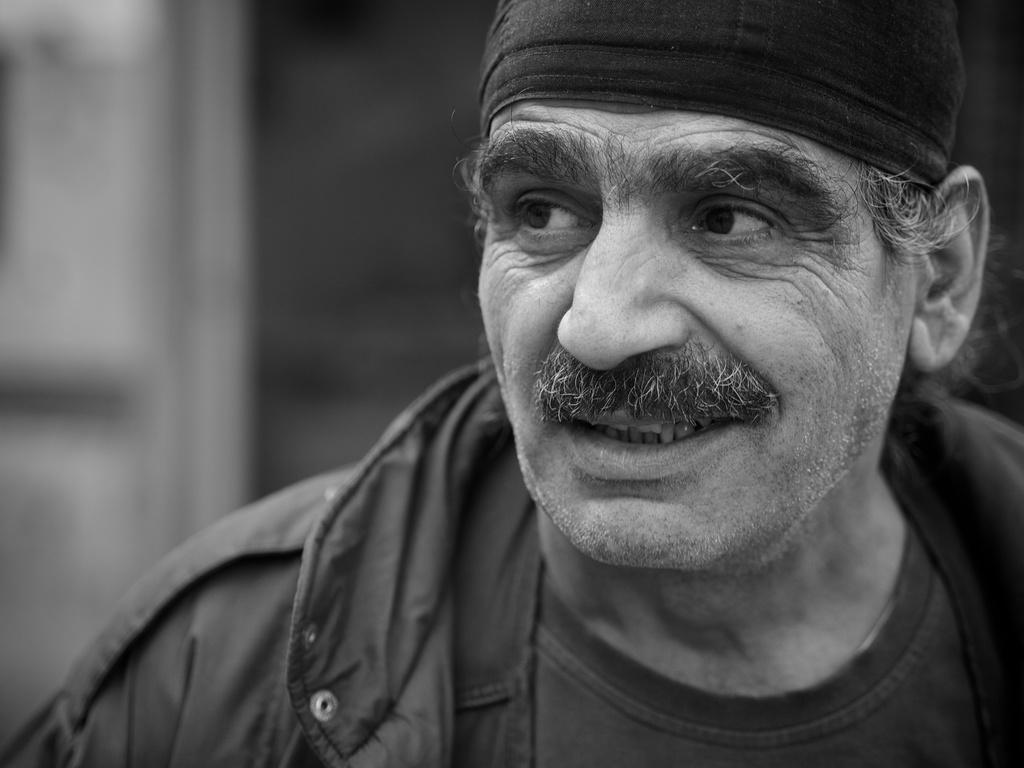What is the color scheme of the image? The image is black and white. Can you describe the person in the image? The person in the image is wearing a jacket and a cap. What is the background of the image like? The background of the image is blurry. What type of arithmetic problem is the person solving in the image? There is no arithmetic problem visible in the image. Can you describe the chair the person is sitting on in the image? There is no chair present in the image. 